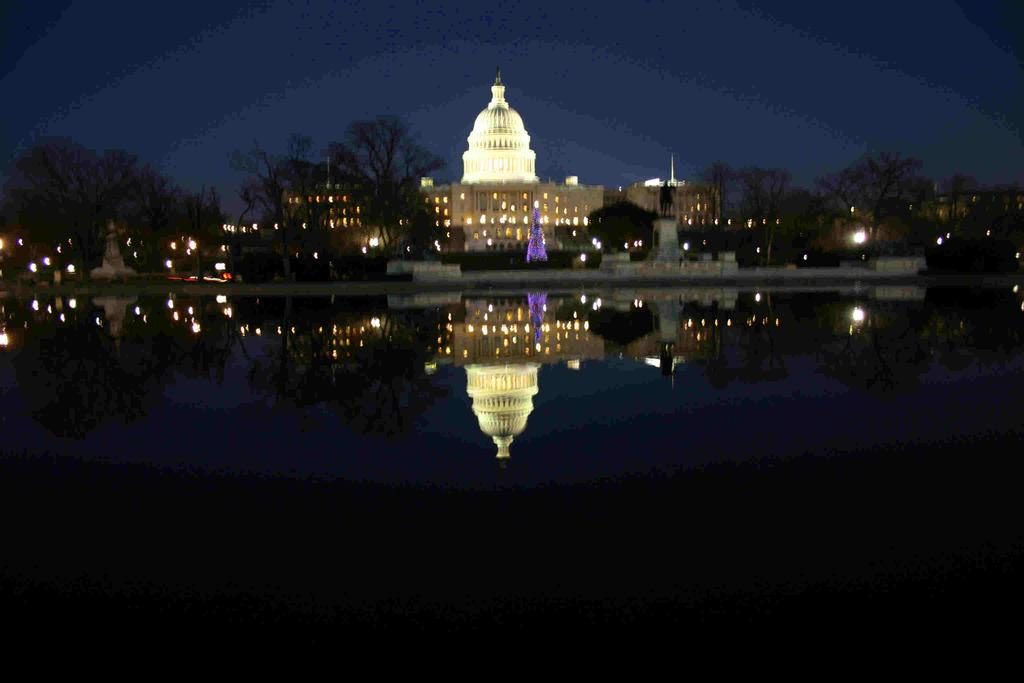What type of structures can be seen in the image? There are buildings in the image. What natural elements are present in the image? There are trees in the image. What type of illumination is visible in the image? There are lights in the image. What body of water can be seen in the image? There is water visible in the image. What part of the natural environment is visible in the image? The sky is visible in the image. What type of ornament is hanging from the trees in the image? There is no ornament hanging from the trees in the image; only trees, buildings, lights, water, and the sky are present. What type of trains can be seen passing by the buildings in the image? There are no trains visible in the image; only buildings, trees, lights, water, and the sky are present. 